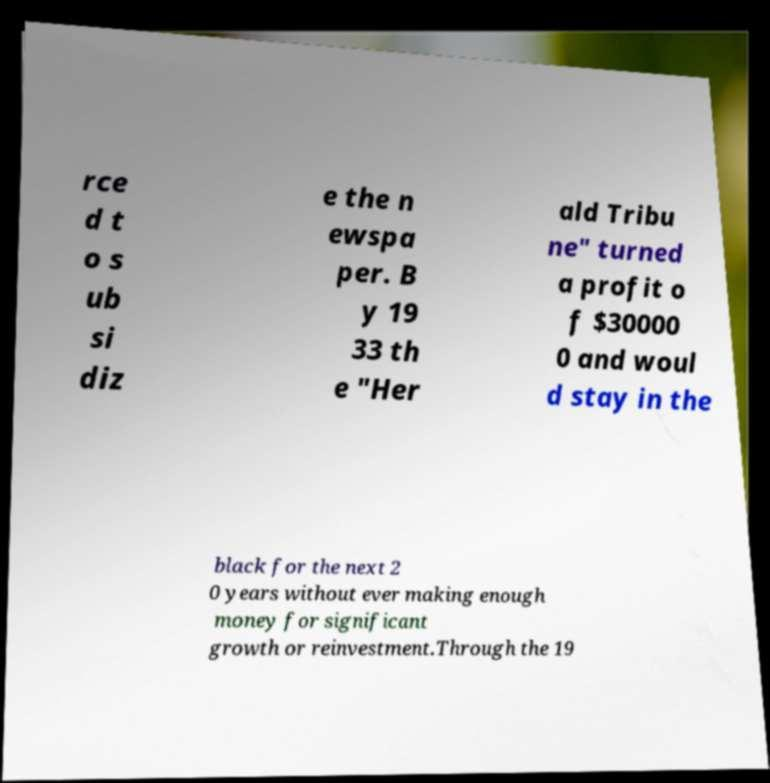Could you extract and type out the text from this image? rce d t o s ub si diz e the n ewspa per. B y 19 33 th e "Her ald Tribu ne" turned a profit o f $30000 0 and woul d stay in the black for the next 2 0 years without ever making enough money for significant growth or reinvestment.Through the 19 